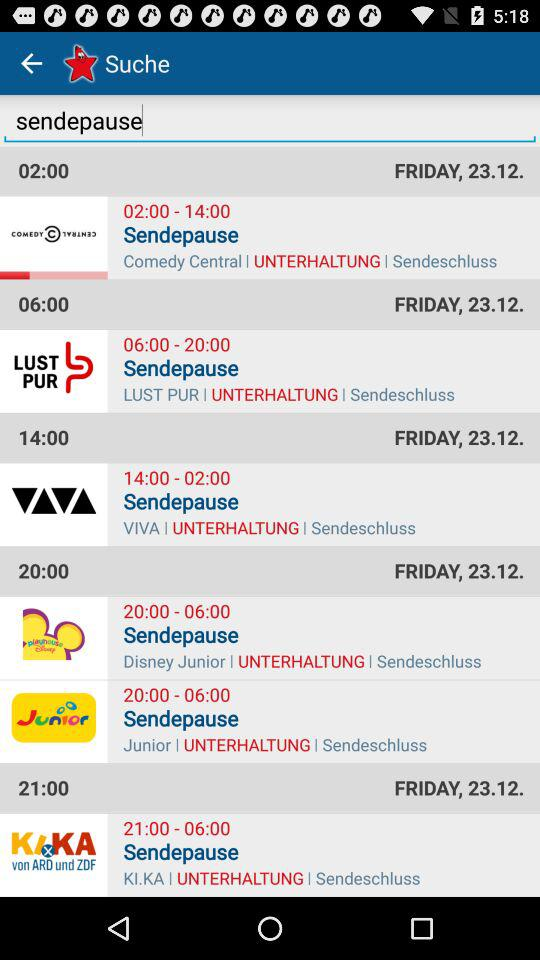What is the time for "VIVA"? The time for "VIVA" is from 14:00 to 02:00. 